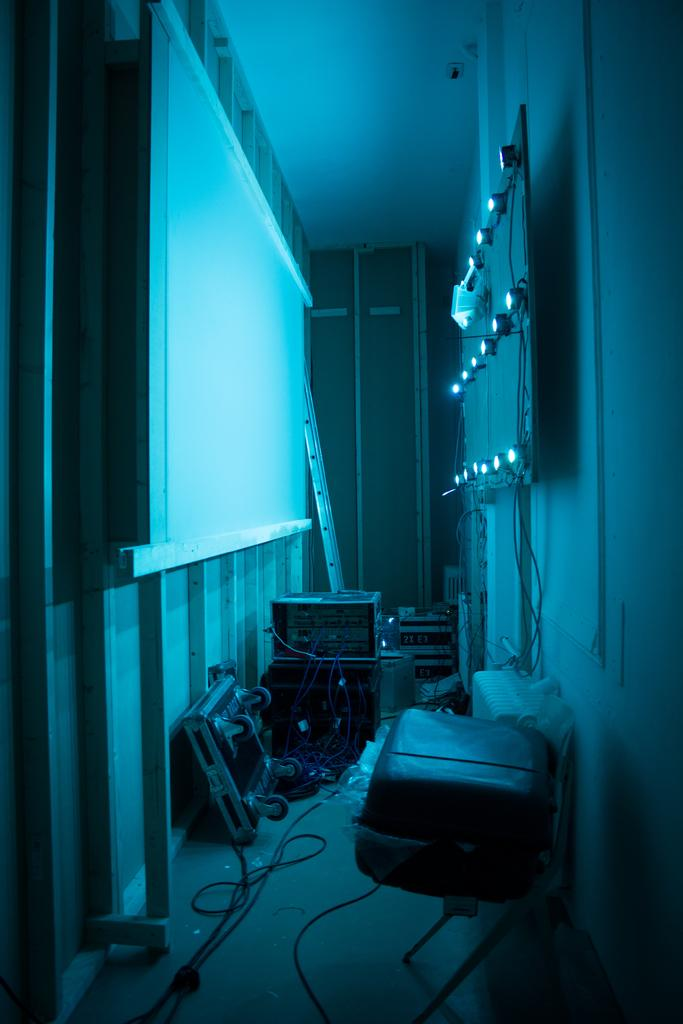Where was the image taken? The image was taken inside a room. What is one of the main features of the room? There is a whiteboard in the room. What other type of board can be seen in the room? There is a board with lights in the room. What might be used for connecting or powering devices in the room? Wires are present in the room. What other unspecified objects might be present in the room? There are other unspecified objects in the room. What type of farm animals can be seen in the image? There are no farm animals present in the image; it is taken inside a room with a whiteboard, a board with lights, and wires. What design elements can be seen on the bean in the image? There is no bean present in the image, and therefore no design elements can be observed. 